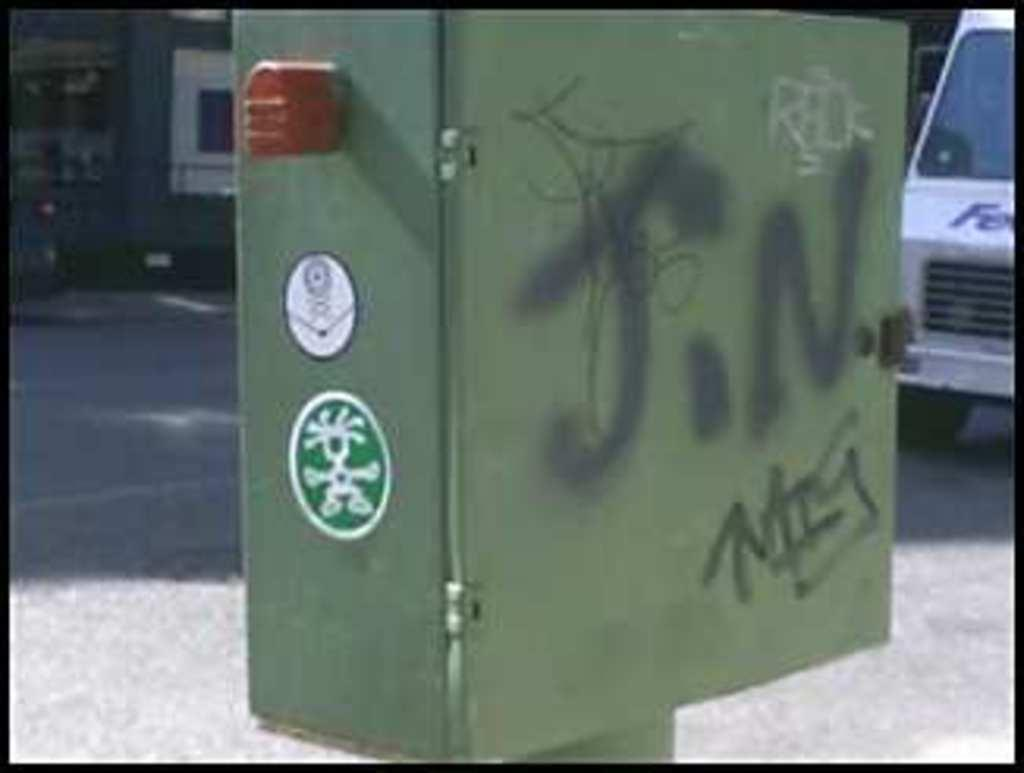What is the main object in the image with writing on it? There is a box with writing in the image. What other visual elements can be seen in the image? There are logos in the image. What can be seen in the distance behind the main objects? There is a road visible in the background. What type of object is present in the image? There is a vehicle in the image. How would you describe the overall appearance of the background? The background appears blurry. How many volleyballs are being played with in the image? There are no volleyballs present in the image. What type of substance is being transported by the cattle in the image? There are no cattle or substances present in the image. 